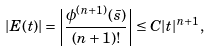<formula> <loc_0><loc_0><loc_500><loc_500>| E ( t ) | = \left | \frac { \phi ^ { ( n + 1 ) } ( \bar { s } ) } { ( n + 1 ) ! } \right | \leq C | t | ^ { n + 1 } ,</formula> 